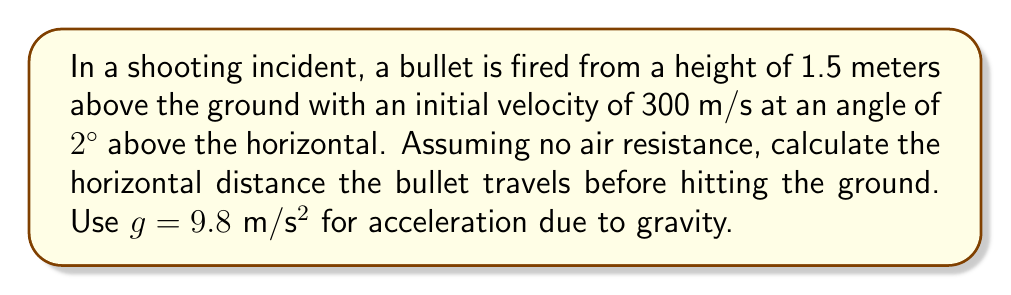Can you solve this math problem? To solve this problem, we'll use the equations of motion for projectile motion. Let's break it down step-by-step:

1) First, let's define our variables:
   $v_0 = 300$ m/s (initial velocity)
   $\theta = 2°$ (angle above horizontal)
   $y_0 = 1.5$ m (initial height)
   $g = 9.8$ m/s² (acceleration due to gravity)

2) We need to find the time it takes for the bullet to hit the ground. We can use the vertical motion equation:

   $$y = y_0 + v_0\sin(\theta)t - \frac{1}{2}gt^2$$

3) At the point of impact, y = 0. So we can solve:

   $$0 = 1.5 + 300\sin(2°)t - \frac{1}{2}(9.8)t^2$$

4) Simplify:
   $$0 = 1.5 + 10.47t - 4.9t^2$$

5) This is a quadratic equation. We can solve it using the quadratic formula:

   $$t = \frac{-b \pm \sqrt{b^2 - 4ac}}{2a}$$

   where $a = -4.9$, $b = 10.47$, and $c = 1.5$

6) Solving this gives us two solutions. We take the positive one:

   $$t \approx 2.14 \text{ seconds}$$

7) Now that we have the time, we can calculate the horizontal distance using:

   $$x = v_0\cos(\theta)t$$

8) Plugging in our values:

   $$x = 300 \cos(2°) * 2.14 \approx 641.3 \text{ meters}$$

Thus, the bullet travels approximately 641.3 meters horizontally before hitting the ground.
Answer: The horizontal distance the bullet travels before hitting the ground is approximately 641.3 meters. 